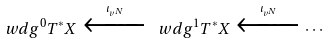<formula> <loc_0><loc_0><loc_500><loc_500>\ w d g ^ { 0 } T ^ { * } X \xleftarrow { \, \iota _ { v ^ { N } } \, } \ w d g ^ { 1 } T ^ { * } X \xleftarrow { \, \iota _ { v ^ { N } } \, } \cdots</formula> 